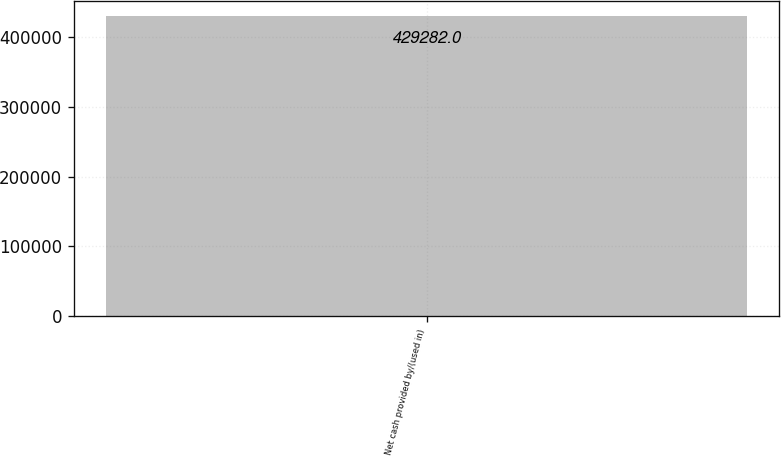Convert chart to OTSL. <chart><loc_0><loc_0><loc_500><loc_500><bar_chart><fcel>Net cash provided by/(used in)<nl><fcel>429282<nl></chart> 